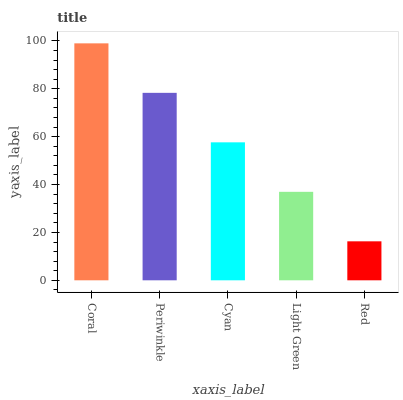Is Red the minimum?
Answer yes or no. Yes. Is Coral the maximum?
Answer yes or no. Yes. Is Periwinkle the minimum?
Answer yes or no. No. Is Periwinkle the maximum?
Answer yes or no. No. Is Coral greater than Periwinkle?
Answer yes or no. Yes. Is Periwinkle less than Coral?
Answer yes or no. Yes. Is Periwinkle greater than Coral?
Answer yes or no. No. Is Coral less than Periwinkle?
Answer yes or no. No. Is Cyan the high median?
Answer yes or no. Yes. Is Cyan the low median?
Answer yes or no. Yes. Is Coral the high median?
Answer yes or no. No. Is Red the low median?
Answer yes or no. No. 